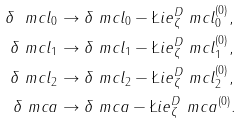Convert formula to latex. <formula><loc_0><loc_0><loc_500><loc_500>\delta \ m c l _ { 0 } & \to \delta \ m c l _ { 0 } - \L i e ^ { D } _ { \zeta } \ m c l _ { 0 } ^ { ( 0 ) } , \\ \delta \ m c l _ { 1 } & \to \delta \ m c l _ { 1 } - \L i e ^ { D } _ { \zeta } \ m c l _ { 1 } ^ { ( 0 ) } , \\ \delta \ m c l _ { 2 } & \to \delta \ m c l _ { 2 } - \L i e ^ { D } _ { \zeta } \ m c l _ { 2 } ^ { ( 0 ) } , \\ \delta \ m c a & \to \delta \ m c a - \L i e ^ { D } _ { \zeta } \ m c a ^ { ( 0 ) } .</formula> 